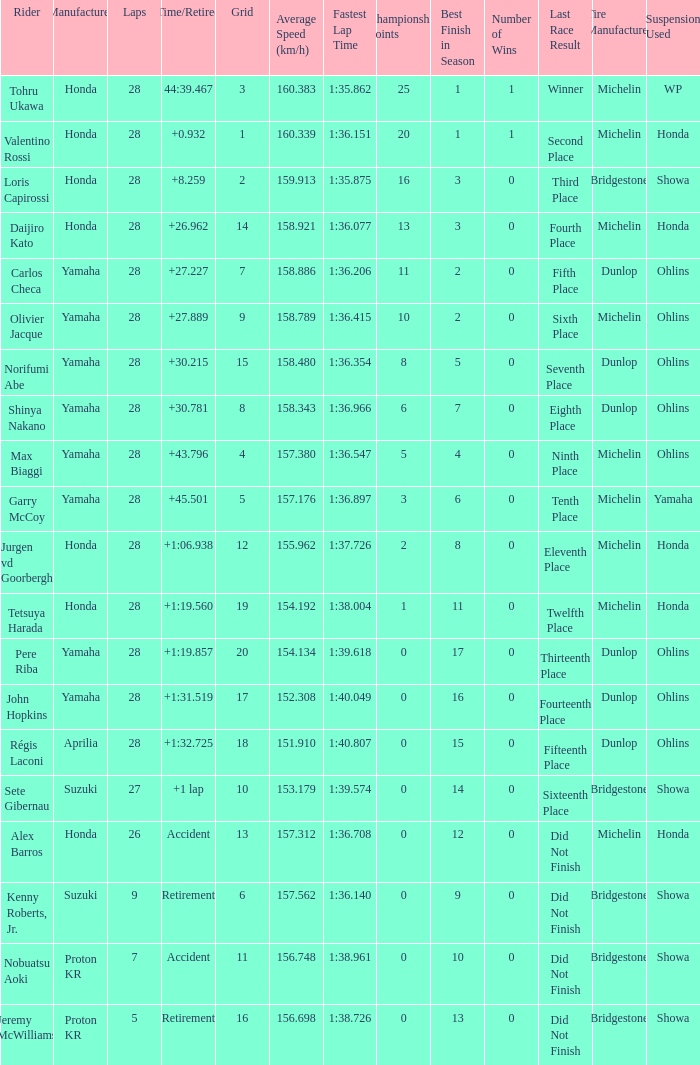What was the total number of laps completed by pere riba? 28.0. Would you be able to parse every entry in this table? {'header': ['Rider', 'Manufacturer', 'Laps', 'Time/Retired', 'Grid', 'Average Speed (km/h)', 'Fastest Lap Time', 'Championship Points', 'Best Finish in Season', 'Number of Wins', 'Last Race Result', 'Tire Manufacturer', 'Suspension Used '], 'rows': [['Tohru Ukawa', 'Honda', '28', '44:39.467', '3', '160.383', '1:35.862', '25', '1', '1', 'Winner', 'Michelin', 'WP'], ['Valentino Rossi', 'Honda', '28', '+0.932', '1', '160.339', '1:36.151', '20', '1', '1', 'Second Place', 'Michelin', 'Honda'], ['Loris Capirossi', 'Honda', '28', '+8.259', '2', '159.913', '1:35.875', '16', '3', '0', 'Third Place', 'Bridgestone', 'Showa'], ['Daijiro Kato', 'Honda', '28', '+26.962', '14', '158.921', '1:36.077', '13', '3', '0', 'Fourth Place', 'Michelin', 'Honda'], ['Carlos Checa', 'Yamaha', '28', '+27.227', '7', '158.886', '1:36.206', '11', '2', '0', 'Fifth Place', 'Dunlop', 'Ohlins'], ['Olivier Jacque', 'Yamaha', '28', '+27.889', '9', '158.789', '1:36.415', '10', '2', '0', 'Sixth Place', 'Michelin', 'Ohlins'], ['Norifumi Abe', 'Yamaha', '28', '+30.215', '15', '158.480', '1:36.354', '8', '5', '0', 'Seventh Place', 'Dunlop', 'Ohlins'], ['Shinya Nakano', 'Yamaha', '28', '+30.781', '8', '158.343', '1:36.966', '6', '7', '0', 'Eighth Place', 'Dunlop', 'Ohlins'], ['Max Biaggi', 'Yamaha', '28', '+43.796', '4', '157.380', '1:36.547', '5', '4', '0', 'Ninth Place', 'Michelin', 'Ohlins'], ['Garry McCoy', 'Yamaha', '28', '+45.501', '5', '157.176', '1:36.897', '3', '6', '0', 'Tenth Place', 'Michelin', 'Yamaha'], ['Jurgen vd Goorbergh', 'Honda', '28', '+1:06.938', '12', '155.962', '1:37.726', '2', '8', '0', 'Eleventh Place', 'Michelin', 'Honda'], ['Tetsuya Harada', 'Honda', '28', '+1:19.560', '19', '154.192', '1:38.004', '1', '11', '0', 'Twelfth Place', 'Michelin', 'Honda'], ['Pere Riba', 'Yamaha', '28', '+1:19.857', '20', '154.134', '1:39.618', '0', '17', '0', 'Thirteenth Place', 'Dunlop', 'Ohlins'], ['John Hopkins', 'Yamaha', '28', '+1:31.519', '17', '152.308', '1:40.049', '0', '16', '0', 'Fourteenth Place', 'Dunlop', 'Ohlins'], ['Régis Laconi', 'Aprilia', '28', '+1:32.725', '18', '151.910', '1:40.807', '0', '15', '0', 'Fifteenth Place', 'Dunlop', 'Ohlins'], ['Sete Gibernau', 'Suzuki', '27', '+1 lap', '10', '153.179', '1:39.574', '0', '14', '0', 'Sixteenth Place', 'Bridgestone', 'Showa'], ['Alex Barros', 'Honda', '26', 'Accident', '13', '157.312', '1:36.708', '0', '12', '0', 'Did Not Finish', 'Michelin', 'Honda'], ['Kenny Roberts, Jr.', 'Suzuki', '9', 'Retirement', '6', '157.562', '1:36.140', '0', '9', '0', 'Did Not Finish', 'Bridgestone', 'Showa'], ['Nobuatsu Aoki', 'Proton KR', '7', 'Accident', '11', '156.748', '1:38.961', '0', '10', '0', 'Did Not Finish', 'Bridgestone', 'Showa'], ['Jeremy McWilliams', 'Proton KR', '5', 'Retirement', '16', '156.698', '1:38.726', '0', '13', '0', 'Did Not Finish', 'Bridgestone', 'Showa']]} 